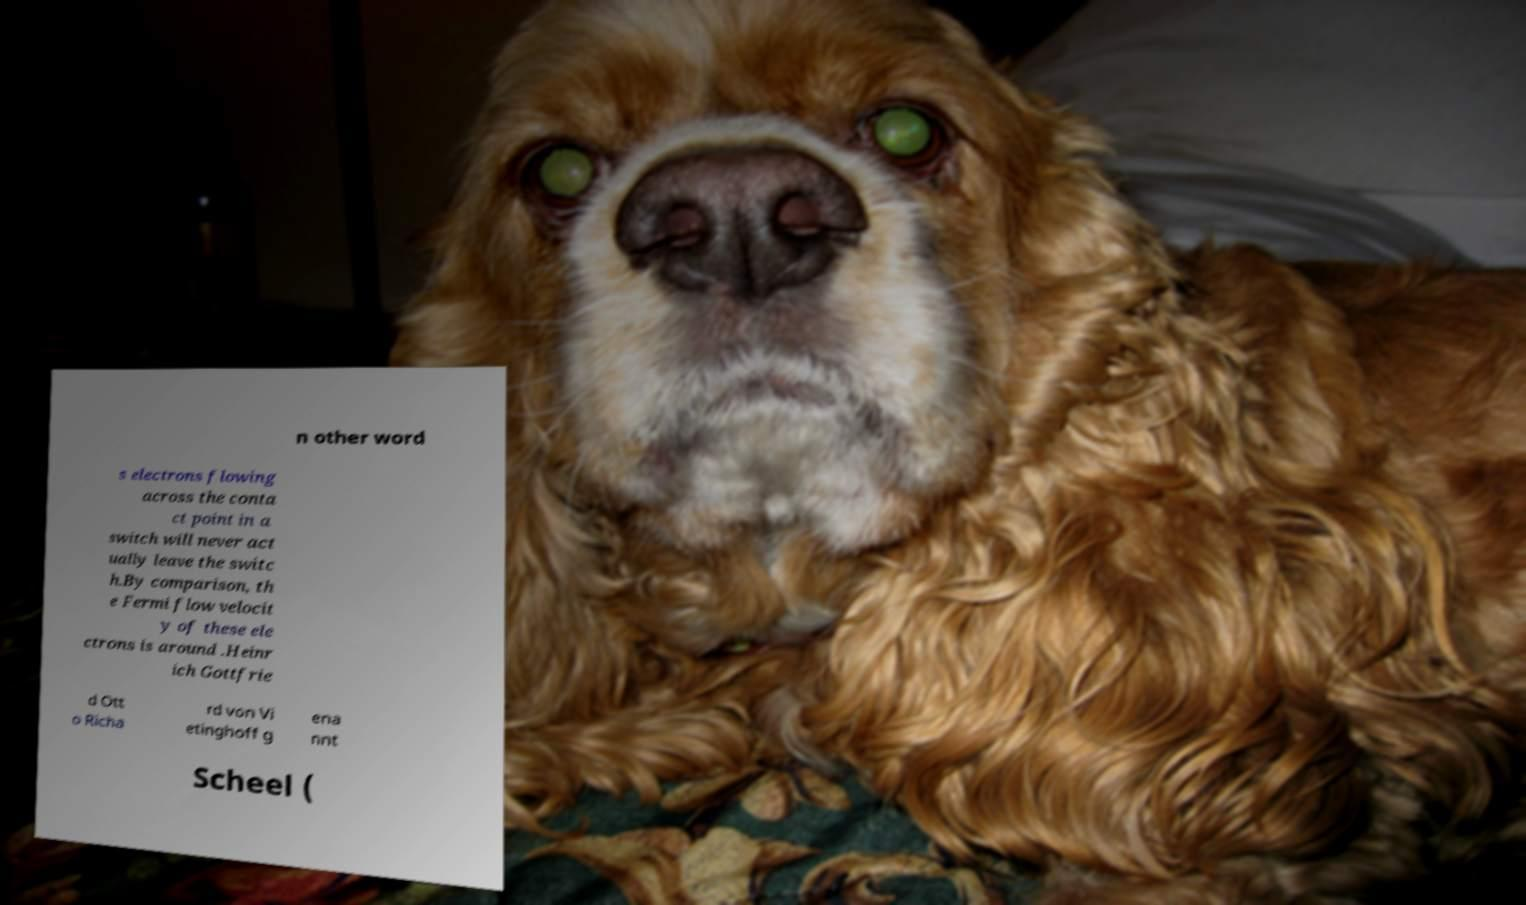Could you extract and type out the text from this image? n other word s electrons flowing across the conta ct point in a switch will never act ually leave the switc h.By comparison, th e Fermi flow velocit y of these ele ctrons is around .Heinr ich Gottfrie d Ott o Richa rd von Vi etinghoff g ena nnt Scheel ( 